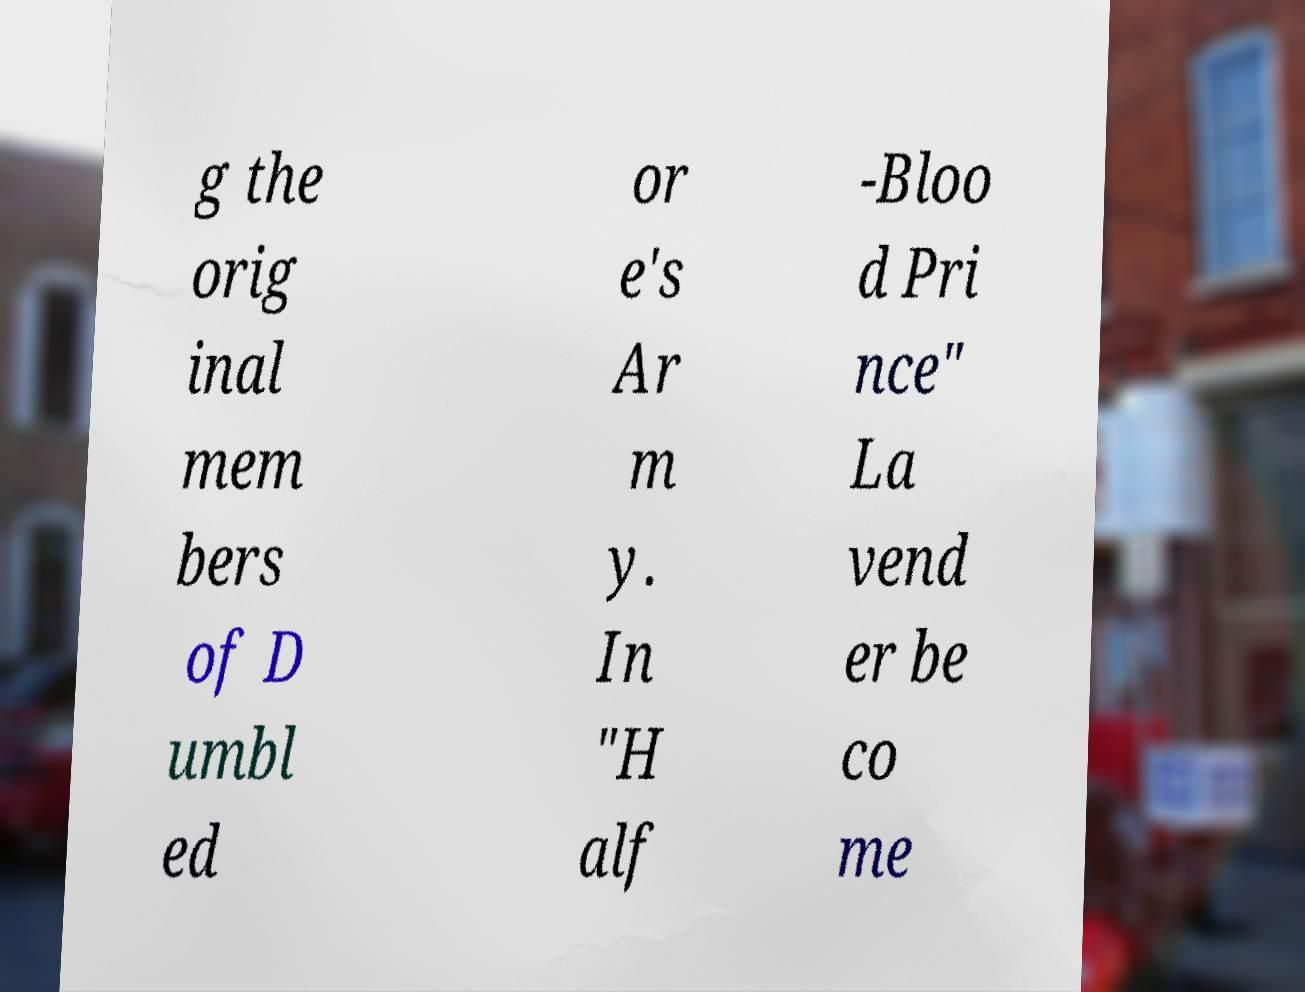Please identify and transcribe the text found in this image. g the orig inal mem bers of D umbl ed or e's Ar m y. In "H alf -Bloo d Pri nce" La vend er be co me 